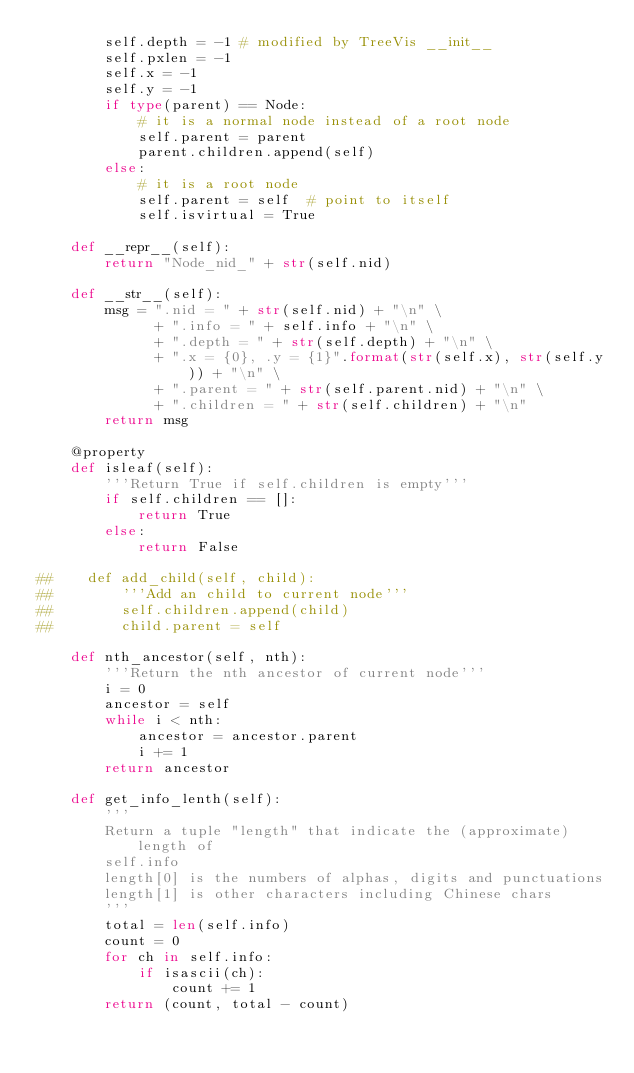<code> <loc_0><loc_0><loc_500><loc_500><_Python_>        self.depth = -1 # modified by TreeVis __init__
        self.pxlen = -1
        self.x = -1
        self.y = -1
        if type(parent) == Node:
            # it is a normal node instead of a root node
            self.parent = parent
            parent.children.append(self)
        else:
            # it is a root node
            self.parent = self  # point to itself
            self.isvirtual = True

    def __repr__(self):
        return "Node_nid_" + str(self.nid)

    def __str__(self):
        msg = ".nid = " + str(self.nid) + "\n" \
              + ".info = " + self.info + "\n" \
              + ".depth = " + str(self.depth) + "\n" \
              + ".x = {0}, .y = {1}".format(str(self.x), str(self.y)) + "\n" \
              + ".parent = " + str(self.parent.nid) + "\n" \
              + ".children = " + str(self.children) + "\n"
        return msg

    @property
    def isleaf(self):
        '''Return True if self.children is empty'''
        if self.children == []:
            return True
        else:
            return False
        
##    def add_child(self, child):
##        '''Add an child to current node'''
##        self.children.append(child)
##        child.parent = self

    def nth_ancestor(self, nth):
        '''Return the nth ancestor of current node'''
        i = 0
        ancestor = self
        while i < nth:
            ancestor = ancestor.parent
            i += 1
        return ancestor

    def get_info_lenth(self):
        '''
        Return a tuple "length" that indicate the (approximate) length of
        self.info
        length[0] is the numbers of alphas, digits and punctuations
        length[1] is other characters including Chinese chars
        '''
        total = len(self.info)
        count = 0
        for ch in self.info:
            if isascii(ch):
                count += 1
        return (count, total - count)
</code> 